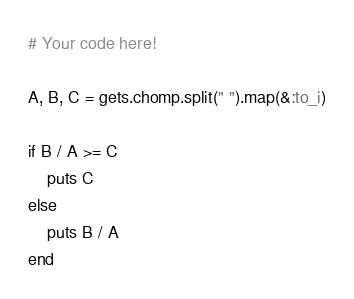<code> <loc_0><loc_0><loc_500><loc_500><_Ruby_># Your code here!

A, B, C = gets.chomp.split(" ").map(&:to_i)

if B / A >= C
    puts C
else
    puts B / A
end</code> 